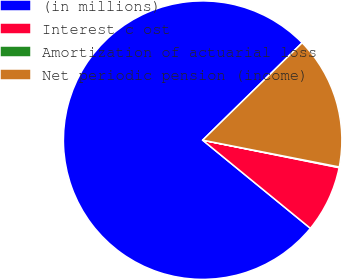Convert chart. <chart><loc_0><loc_0><loc_500><loc_500><pie_chart><fcel>(in millions)<fcel>Interest c ost<fcel>Amortization of actuarial loss<fcel>Net periodic pension (income)<nl><fcel>76.76%<fcel>7.75%<fcel>0.08%<fcel>15.41%<nl></chart> 